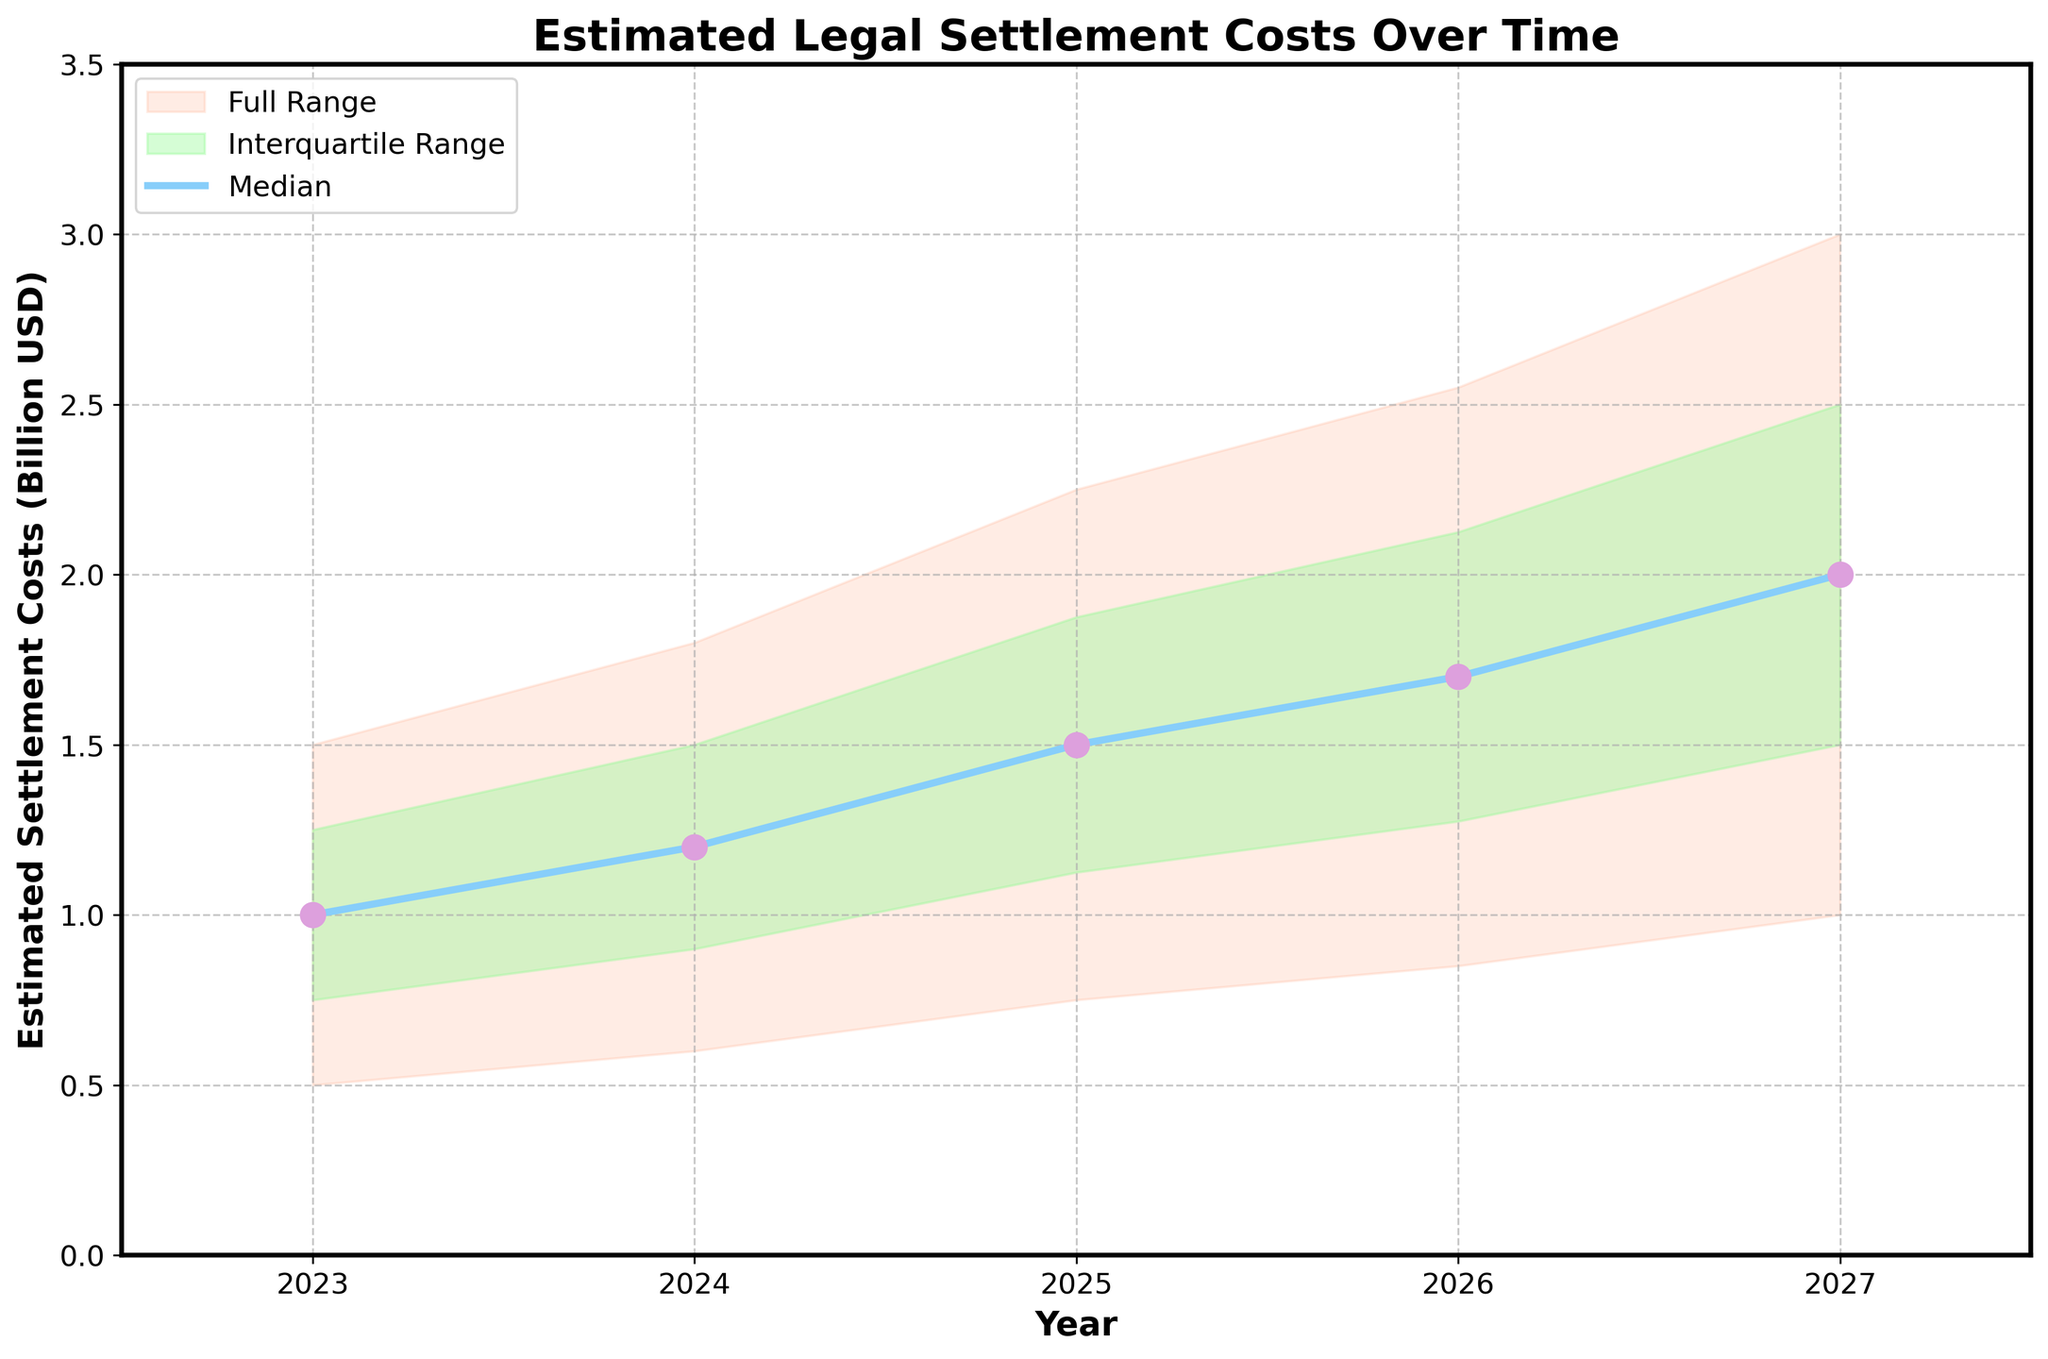What's the title of the figure? The title text can be found at the top or center of the figure above the visual plot area. The title of this figure above the plot area is 'Estimated Legal Settlement Costs Over Time'.
Answer: Estimated Legal Settlement Costs Over Time What do the x-axis and y-axis represent in the figure? The x-axis represents the "Year" ranging from 2023 to 2027, and the y-axis represents "Estimated Settlement Costs (Billion USD)", indicating the monetary cost in billion US dollars.
Answer: Year; Estimated Settlement Costs (Billion USD) How many years are displayed in the figure? The x-axis shows data points for five distinct years, and these can be confirmed by counting the labeled tick marks on the x-axis.
Answer: 5 What's the median estimated settlement cost for 2023, and how is it indicated in the figure? The median value for 2023 is specifically shown along the dark blue line labeled "Median" and can be read directly on the axis or from the corresponding table data. For 2023, this is positioned at 1 billion USD.
Answer: 1 billion USD How does the median estimated settlement cost change from 2023 to 2024? We compare the median value for 2023 (1 billion USD) to the median value for 2024 (1.2 billion USD) shown by the dark blue line across these years. The change can be computed as 1.2 billion USD - 1 billion USD.
Answer: Increases by 0.2 billion USD What's the difference between the high estimate and low estimate for 2027? We read the high and low estimates for 2027 from the plot (lines in the plot showing the boundaries of the shaded regions). The high estimate is 3 billion USD, and the low estimate is 1 billion USD. The difference is calculated as 3 billion USD - 1 billion USD.
Answer: 2 billion USD In which year is the range between the 25th percentile and the 75th percentile the widest? To determine this, we look at the green shaded area (representing the interquartile range) and observe its width across the years. The widest range within these bounds is seen for the year 2027.
Answer: 2027 Which year has the largest increase in the high estimate when compared to the previous year? We calculate the yearly increase in the high estimate by subtracting the high estimate of one year from the high estimate of the previous year for all years. The highest increase observed is from 2023 to 2024 (1.8 billion USD - 1.5 billion USD).
Answer: 2024 Considering the median values, how much does the median estimated settlement cost increase from 2023 to 2027? We subtract the median value for 2023 (1 billion USD) from the median value for 2027 (2 billion USD) to get the increase over the entire span.
Answer: 1 billion USD 